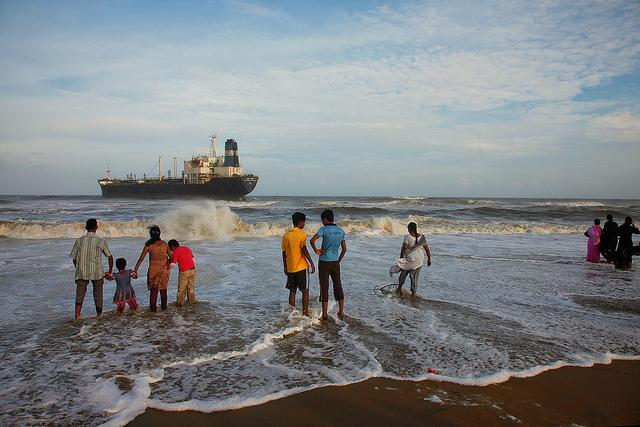How many people are visible? Please explain your reasoning. ten. There are a total of ten people in the water. 